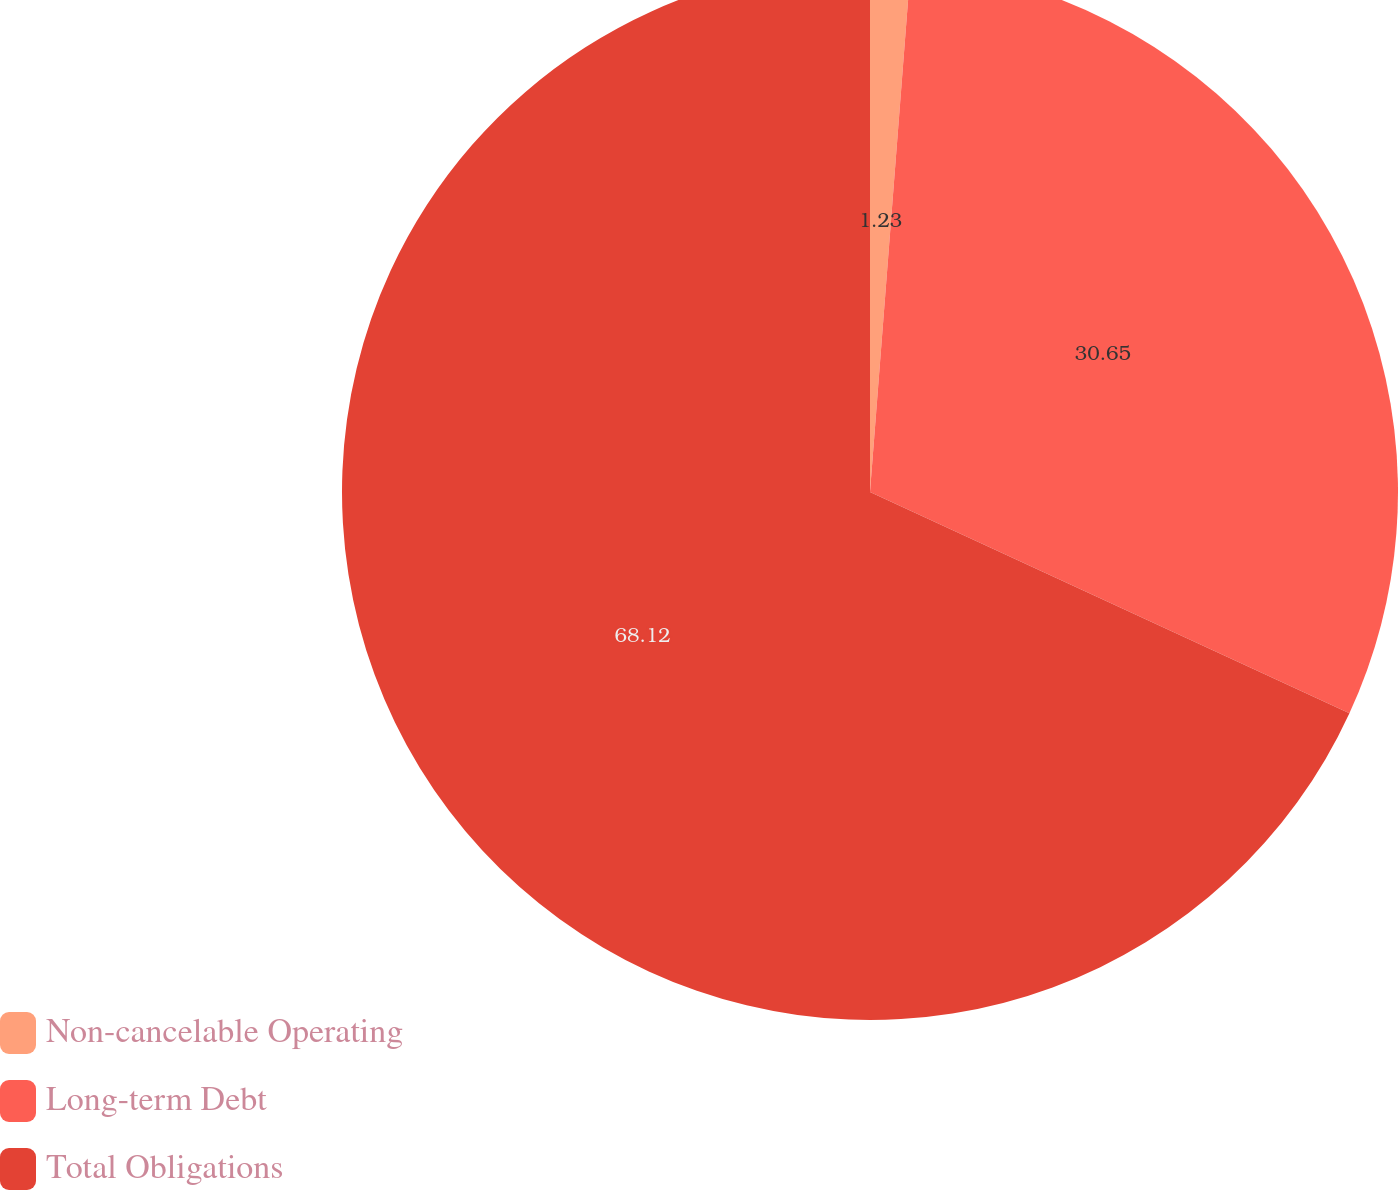Convert chart. <chart><loc_0><loc_0><loc_500><loc_500><pie_chart><fcel>Non-cancelable Operating<fcel>Long-term Debt<fcel>Total Obligations<nl><fcel>1.23%<fcel>30.65%<fcel>68.12%<nl></chart> 